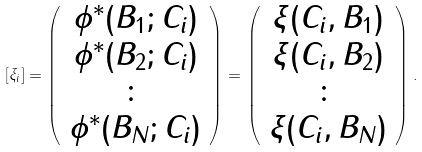Convert formula to latex. <formula><loc_0><loc_0><loc_500><loc_500>[ \xi _ { i } ] = \left ( \begin{array} { c } \phi ^ { * } ( B _ { 1 } ; C _ { i } ) \\ \phi ^ { * } ( B _ { 2 } ; C _ { i } ) \\ \colon \\ \phi ^ { * } ( B _ { N } ; C _ { i } ) \end{array} \right ) = \left ( \begin{array} { c } \xi ( C _ { i } , B _ { 1 } ) \\ \xi ( C _ { i } , B _ { 2 } ) \\ \colon \\ \xi ( C _ { i } , B _ { N } ) \end{array} \right ) .</formula> 